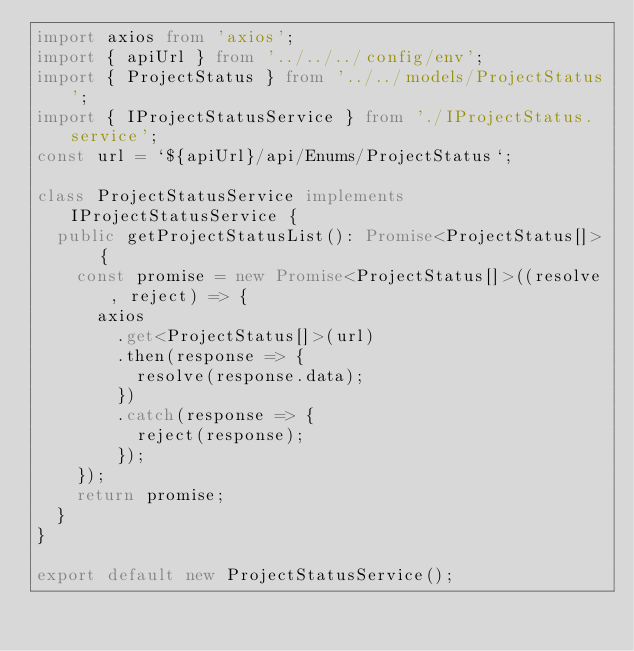<code> <loc_0><loc_0><loc_500><loc_500><_TypeScript_>import axios from 'axios';
import { apiUrl } from '../../../config/env';
import { ProjectStatus } from '../../models/ProjectStatus';
import { IProjectStatusService } from './IProjectStatus.service';
const url = `${apiUrl}/api/Enums/ProjectStatus`;

class ProjectStatusService implements IProjectStatusService {
  public getProjectStatusList(): Promise<ProjectStatus[]> {
    const promise = new Promise<ProjectStatus[]>((resolve, reject) => {
      axios
        .get<ProjectStatus[]>(url)
        .then(response => {
          resolve(response.data);
        })
        .catch(response => {
          reject(response);
        });
    });
    return promise;
  }
}

export default new ProjectStatusService();
</code> 